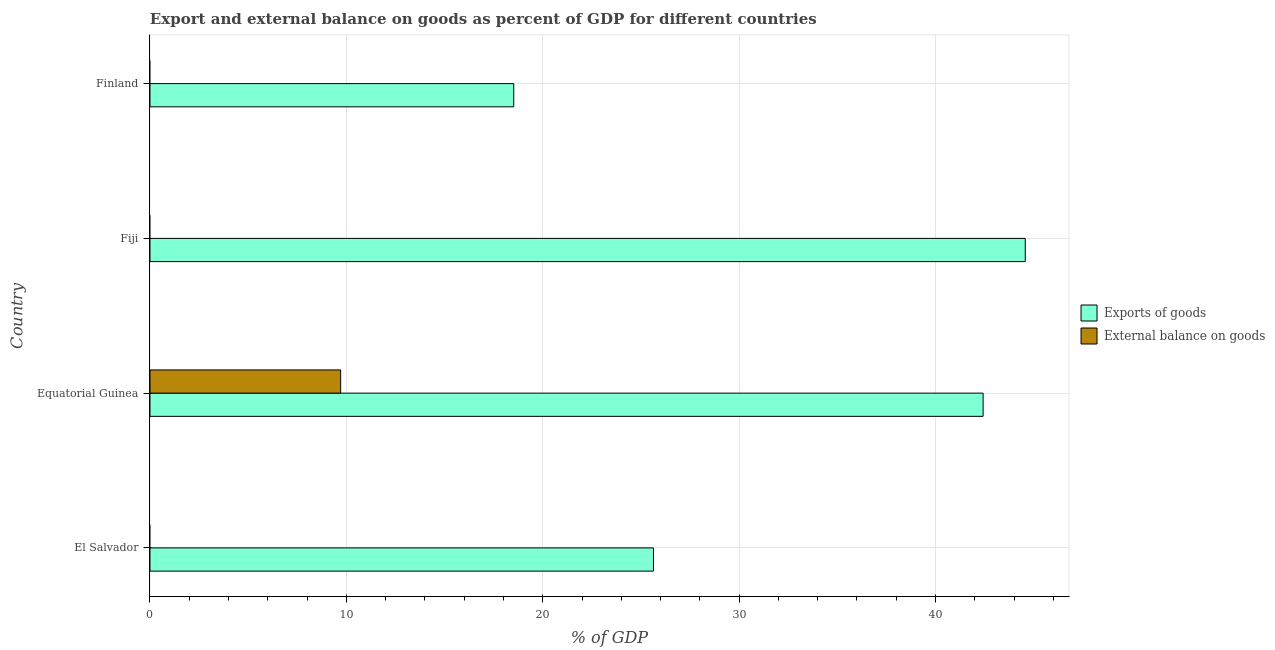How many different coloured bars are there?
Provide a short and direct response. 2. Are the number of bars per tick equal to the number of legend labels?
Your answer should be compact. No. Are the number of bars on each tick of the Y-axis equal?
Provide a short and direct response. No. How many bars are there on the 4th tick from the top?
Keep it short and to the point. 1. How many bars are there on the 4th tick from the bottom?
Ensure brevity in your answer.  1. What is the label of the 4th group of bars from the top?
Provide a succinct answer. El Salvador. In how many cases, is the number of bars for a given country not equal to the number of legend labels?
Provide a short and direct response. 3. What is the export of goods as percentage of gdp in Fiji?
Keep it short and to the point. 44.57. Across all countries, what is the maximum export of goods as percentage of gdp?
Offer a very short reply. 44.57. Across all countries, what is the minimum export of goods as percentage of gdp?
Offer a very short reply. 18.52. In which country was the export of goods as percentage of gdp maximum?
Your answer should be compact. Fiji. What is the total export of goods as percentage of gdp in the graph?
Give a very brief answer. 131.16. What is the difference between the export of goods as percentage of gdp in Equatorial Guinea and that in Fiji?
Your answer should be compact. -2.15. What is the difference between the external balance on goods as percentage of gdp in Equatorial Guinea and the export of goods as percentage of gdp in El Salvador?
Make the answer very short. -15.93. What is the average external balance on goods as percentage of gdp per country?
Your response must be concise. 2.43. What is the difference between the external balance on goods as percentage of gdp and export of goods as percentage of gdp in Equatorial Guinea?
Give a very brief answer. -32.72. What is the ratio of the export of goods as percentage of gdp in El Salvador to that in Finland?
Give a very brief answer. 1.38. What is the difference between the highest and the second highest export of goods as percentage of gdp?
Your answer should be very brief. 2.15. What is the difference between the highest and the lowest external balance on goods as percentage of gdp?
Keep it short and to the point. 9.71. In how many countries, is the external balance on goods as percentage of gdp greater than the average external balance on goods as percentage of gdp taken over all countries?
Your response must be concise. 1. Are all the bars in the graph horizontal?
Your answer should be very brief. Yes. Are the values on the major ticks of X-axis written in scientific E-notation?
Offer a terse response. No. Does the graph contain any zero values?
Your response must be concise. Yes. How many legend labels are there?
Offer a terse response. 2. What is the title of the graph?
Make the answer very short. Export and external balance on goods as percent of GDP for different countries. Does "Old" appear as one of the legend labels in the graph?
Offer a terse response. No. What is the label or title of the X-axis?
Your response must be concise. % of GDP. What is the % of GDP in Exports of goods in El Salvador?
Your response must be concise. 25.64. What is the % of GDP of External balance on goods in El Salvador?
Give a very brief answer. 0. What is the % of GDP of Exports of goods in Equatorial Guinea?
Provide a short and direct response. 42.43. What is the % of GDP of External balance on goods in Equatorial Guinea?
Keep it short and to the point. 9.71. What is the % of GDP of Exports of goods in Fiji?
Offer a terse response. 44.57. What is the % of GDP in External balance on goods in Fiji?
Ensure brevity in your answer.  0. What is the % of GDP in Exports of goods in Finland?
Your response must be concise. 18.52. What is the % of GDP in External balance on goods in Finland?
Your answer should be compact. 0. Across all countries, what is the maximum % of GDP of Exports of goods?
Keep it short and to the point. 44.57. Across all countries, what is the maximum % of GDP of External balance on goods?
Keep it short and to the point. 9.71. Across all countries, what is the minimum % of GDP of Exports of goods?
Offer a terse response. 18.52. Across all countries, what is the minimum % of GDP of External balance on goods?
Make the answer very short. 0. What is the total % of GDP in Exports of goods in the graph?
Offer a very short reply. 131.16. What is the total % of GDP of External balance on goods in the graph?
Offer a terse response. 9.71. What is the difference between the % of GDP of Exports of goods in El Salvador and that in Equatorial Guinea?
Your answer should be very brief. -16.79. What is the difference between the % of GDP of Exports of goods in El Salvador and that in Fiji?
Ensure brevity in your answer.  -18.93. What is the difference between the % of GDP in Exports of goods in El Salvador and that in Finland?
Ensure brevity in your answer.  7.11. What is the difference between the % of GDP of Exports of goods in Equatorial Guinea and that in Fiji?
Your response must be concise. -2.15. What is the difference between the % of GDP of Exports of goods in Equatorial Guinea and that in Finland?
Ensure brevity in your answer.  23.9. What is the difference between the % of GDP of Exports of goods in Fiji and that in Finland?
Your answer should be very brief. 26.05. What is the difference between the % of GDP in Exports of goods in El Salvador and the % of GDP in External balance on goods in Equatorial Guinea?
Your response must be concise. 15.93. What is the average % of GDP in Exports of goods per country?
Provide a succinct answer. 32.79. What is the average % of GDP of External balance on goods per country?
Make the answer very short. 2.43. What is the difference between the % of GDP in Exports of goods and % of GDP in External balance on goods in Equatorial Guinea?
Your answer should be compact. 32.72. What is the ratio of the % of GDP in Exports of goods in El Salvador to that in Equatorial Guinea?
Ensure brevity in your answer.  0.6. What is the ratio of the % of GDP of Exports of goods in El Salvador to that in Fiji?
Provide a succinct answer. 0.58. What is the ratio of the % of GDP in Exports of goods in El Salvador to that in Finland?
Give a very brief answer. 1.38. What is the ratio of the % of GDP of Exports of goods in Equatorial Guinea to that in Fiji?
Give a very brief answer. 0.95. What is the ratio of the % of GDP in Exports of goods in Equatorial Guinea to that in Finland?
Give a very brief answer. 2.29. What is the ratio of the % of GDP of Exports of goods in Fiji to that in Finland?
Give a very brief answer. 2.41. What is the difference between the highest and the second highest % of GDP in Exports of goods?
Keep it short and to the point. 2.15. What is the difference between the highest and the lowest % of GDP in Exports of goods?
Offer a terse response. 26.05. What is the difference between the highest and the lowest % of GDP of External balance on goods?
Provide a short and direct response. 9.71. 